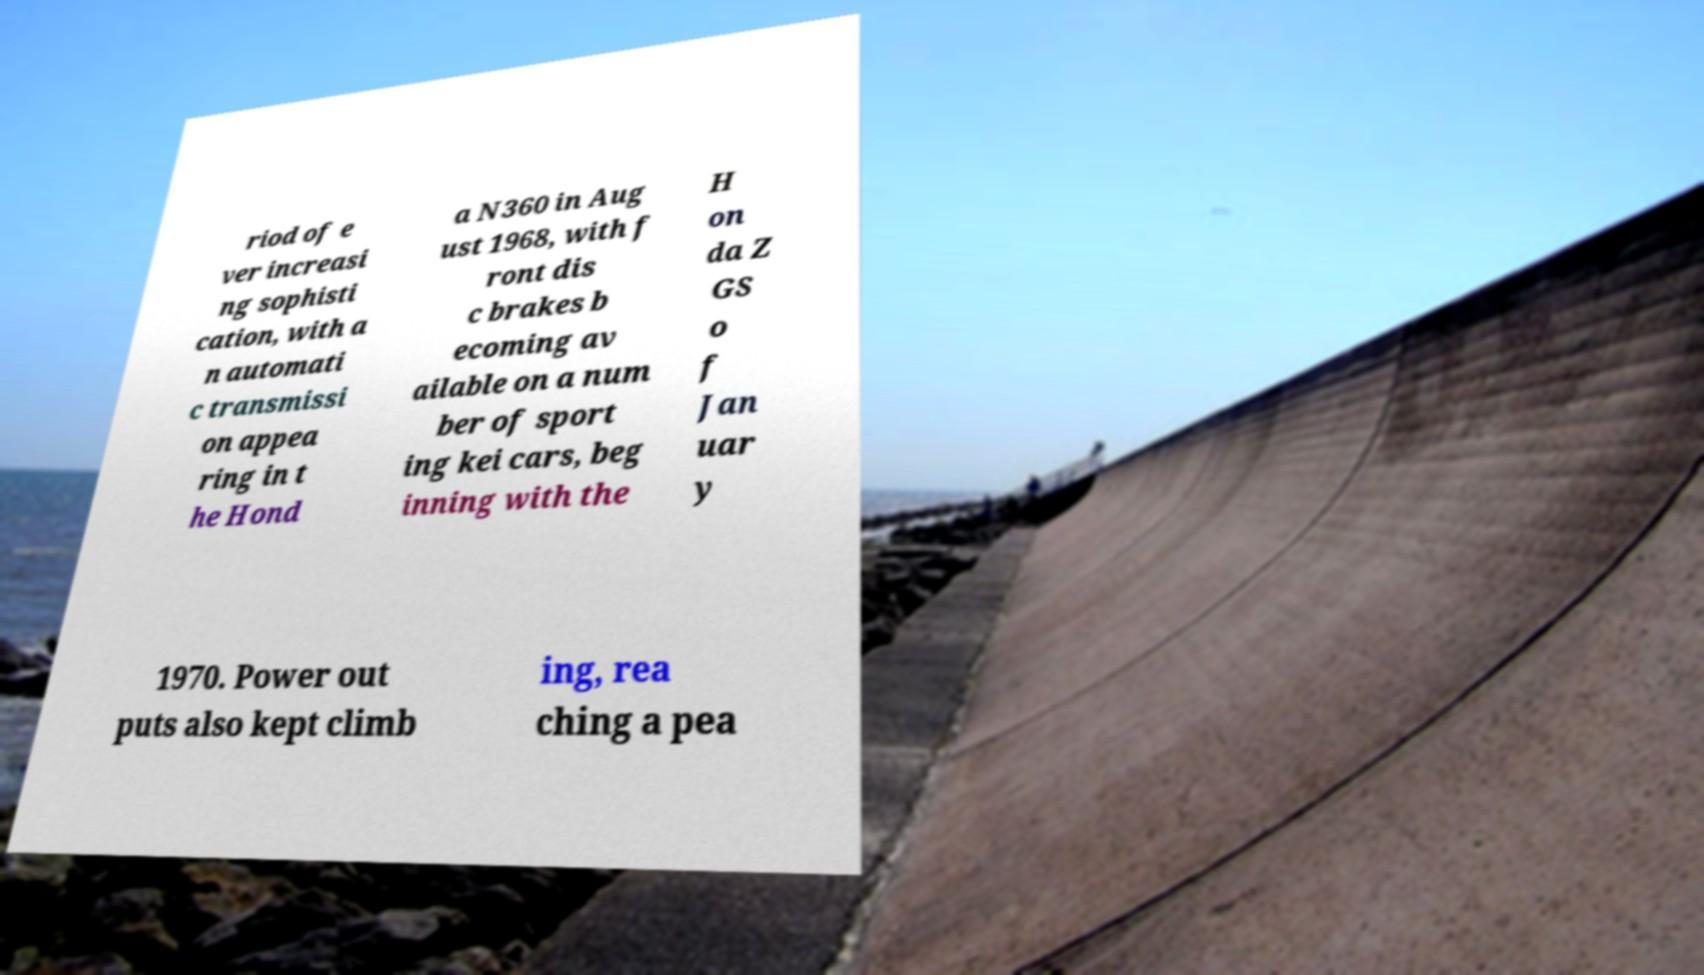Could you assist in decoding the text presented in this image and type it out clearly? riod of e ver increasi ng sophisti cation, with a n automati c transmissi on appea ring in t he Hond a N360 in Aug ust 1968, with f ront dis c brakes b ecoming av ailable on a num ber of sport ing kei cars, beg inning with the H on da Z GS o f Jan uar y 1970. Power out puts also kept climb ing, rea ching a pea 